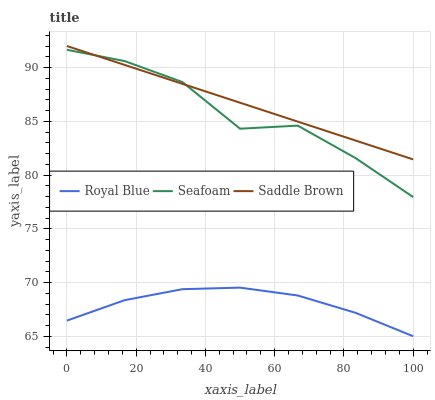Does Royal Blue have the minimum area under the curve?
Answer yes or no. Yes. Does Saddle Brown have the maximum area under the curve?
Answer yes or no. Yes. Does Seafoam have the minimum area under the curve?
Answer yes or no. No. Does Seafoam have the maximum area under the curve?
Answer yes or no. No. Is Saddle Brown the smoothest?
Answer yes or no. Yes. Is Seafoam the roughest?
Answer yes or no. Yes. Is Seafoam the smoothest?
Answer yes or no. No. Is Saddle Brown the roughest?
Answer yes or no. No. Does Seafoam have the lowest value?
Answer yes or no. No. Does Saddle Brown have the highest value?
Answer yes or no. Yes. Does Seafoam have the highest value?
Answer yes or no. No. Is Royal Blue less than Saddle Brown?
Answer yes or no. Yes. Is Seafoam greater than Royal Blue?
Answer yes or no. Yes. Does Seafoam intersect Saddle Brown?
Answer yes or no. Yes. Is Seafoam less than Saddle Brown?
Answer yes or no. No. Is Seafoam greater than Saddle Brown?
Answer yes or no. No. Does Royal Blue intersect Saddle Brown?
Answer yes or no. No. 